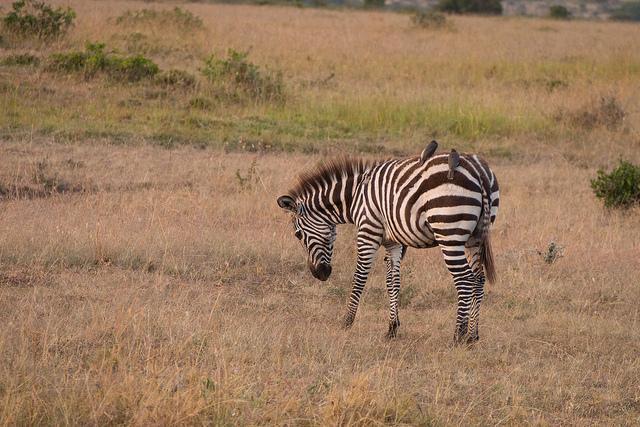How many birds on zebra?
Give a very brief answer. 2. How many zebra are in the picture?
Give a very brief answer. 1. How many zebras are there?
Give a very brief answer. 1. How many zebras are in this picture?
Give a very brief answer. 1. How many types of animals are there?
Give a very brief answer. 1. How many animals are depicted?
Give a very brief answer. 1. How many animals can be seen?
Give a very brief answer. 1. How many people are visible to the left of the cow?
Give a very brief answer. 0. 